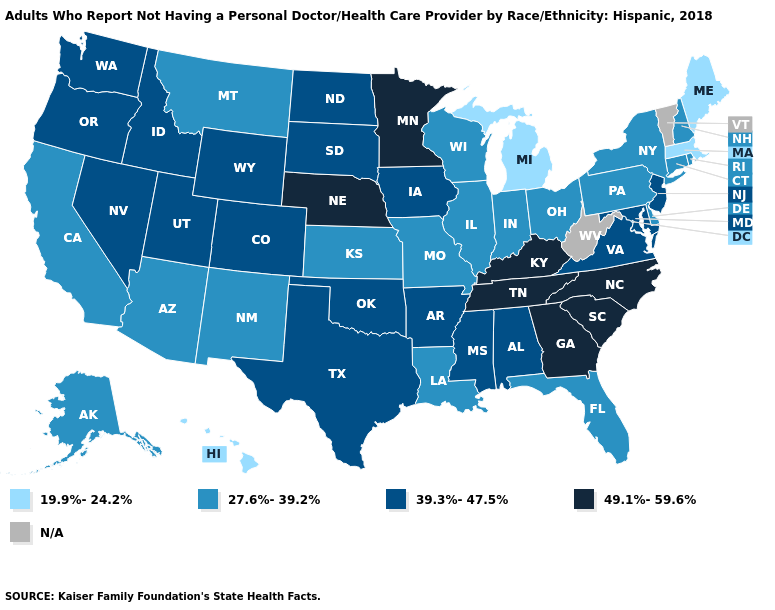Name the states that have a value in the range N/A?
Keep it brief. Vermont, West Virginia. Does Washington have the highest value in the West?
Be succinct. Yes. Which states hav the highest value in the Northeast?
Write a very short answer. New Jersey. Name the states that have a value in the range 49.1%-59.6%?
Give a very brief answer. Georgia, Kentucky, Minnesota, Nebraska, North Carolina, South Carolina, Tennessee. Name the states that have a value in the range 39.3%-47.5%?
Concise answer only. Alabama, Arkansas, Colorado, Idaho, Iowa, Maryland, Mississippi, Nevada, New Jersey, North Dakota, Oklahoma, Oregon, South Dakota, Texas, Utah, Virginia, Washington, Wyoming. Name the states that have a value in the range 19.9%-24.2%?
Give a very brief answer. Hawaii, Maine, Massachusetts, Michigan. What is the lowest value in the West?
Quick response, please. 19.9%-24.2%. Among the states that border Mississippi , which have the lowest value?
Concise answer only. Louisiana. What is the value of California?
Concise answer only. 27.6%-39.2%. What is the value of Washington?
Keep it brief. 39.3%-47.5%. What is the lowest value in the USA?
Give a very brief answer. 19.9%-24.2%. What is the lowest value in the USA?
Give a very brief answer. 19.9%-24.2%. Name the states that have a value in the range 19.9%-24.2%?
Keep it brief. Hawaii, Maine, Massachusetts, Michigan. How many symbols are there in the legend?
Write a very short answer. 5. 